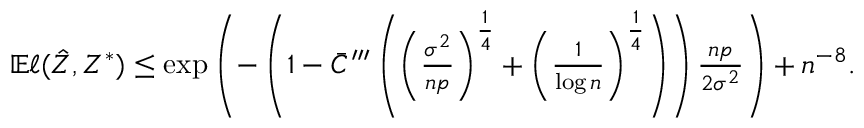Convert formula to latex. <formula><loc_0><loc_0><loc_500><loc_500>\begin{array} { r } { \mathbb { E } \ell ( \hat { Z } , Z ^ { * } ) \leq \exp \left ( - \left ( 1 - \bar { C } ^ { \prime \prime \prime } \left ( \left ( \frac { \sigma ^ { 2 } } { n p } \right ) ^ { \frac { 1 } { 4 } } + \left ( \frac { 1 } { \log n } \right ) ^ { \frac { 1 } { 4 } } \right ) \right ) \frac { n p } { 2 \sigma ^ { 2 } } \right ) + n ^ { - 8 } . } \end{array}</formula> 